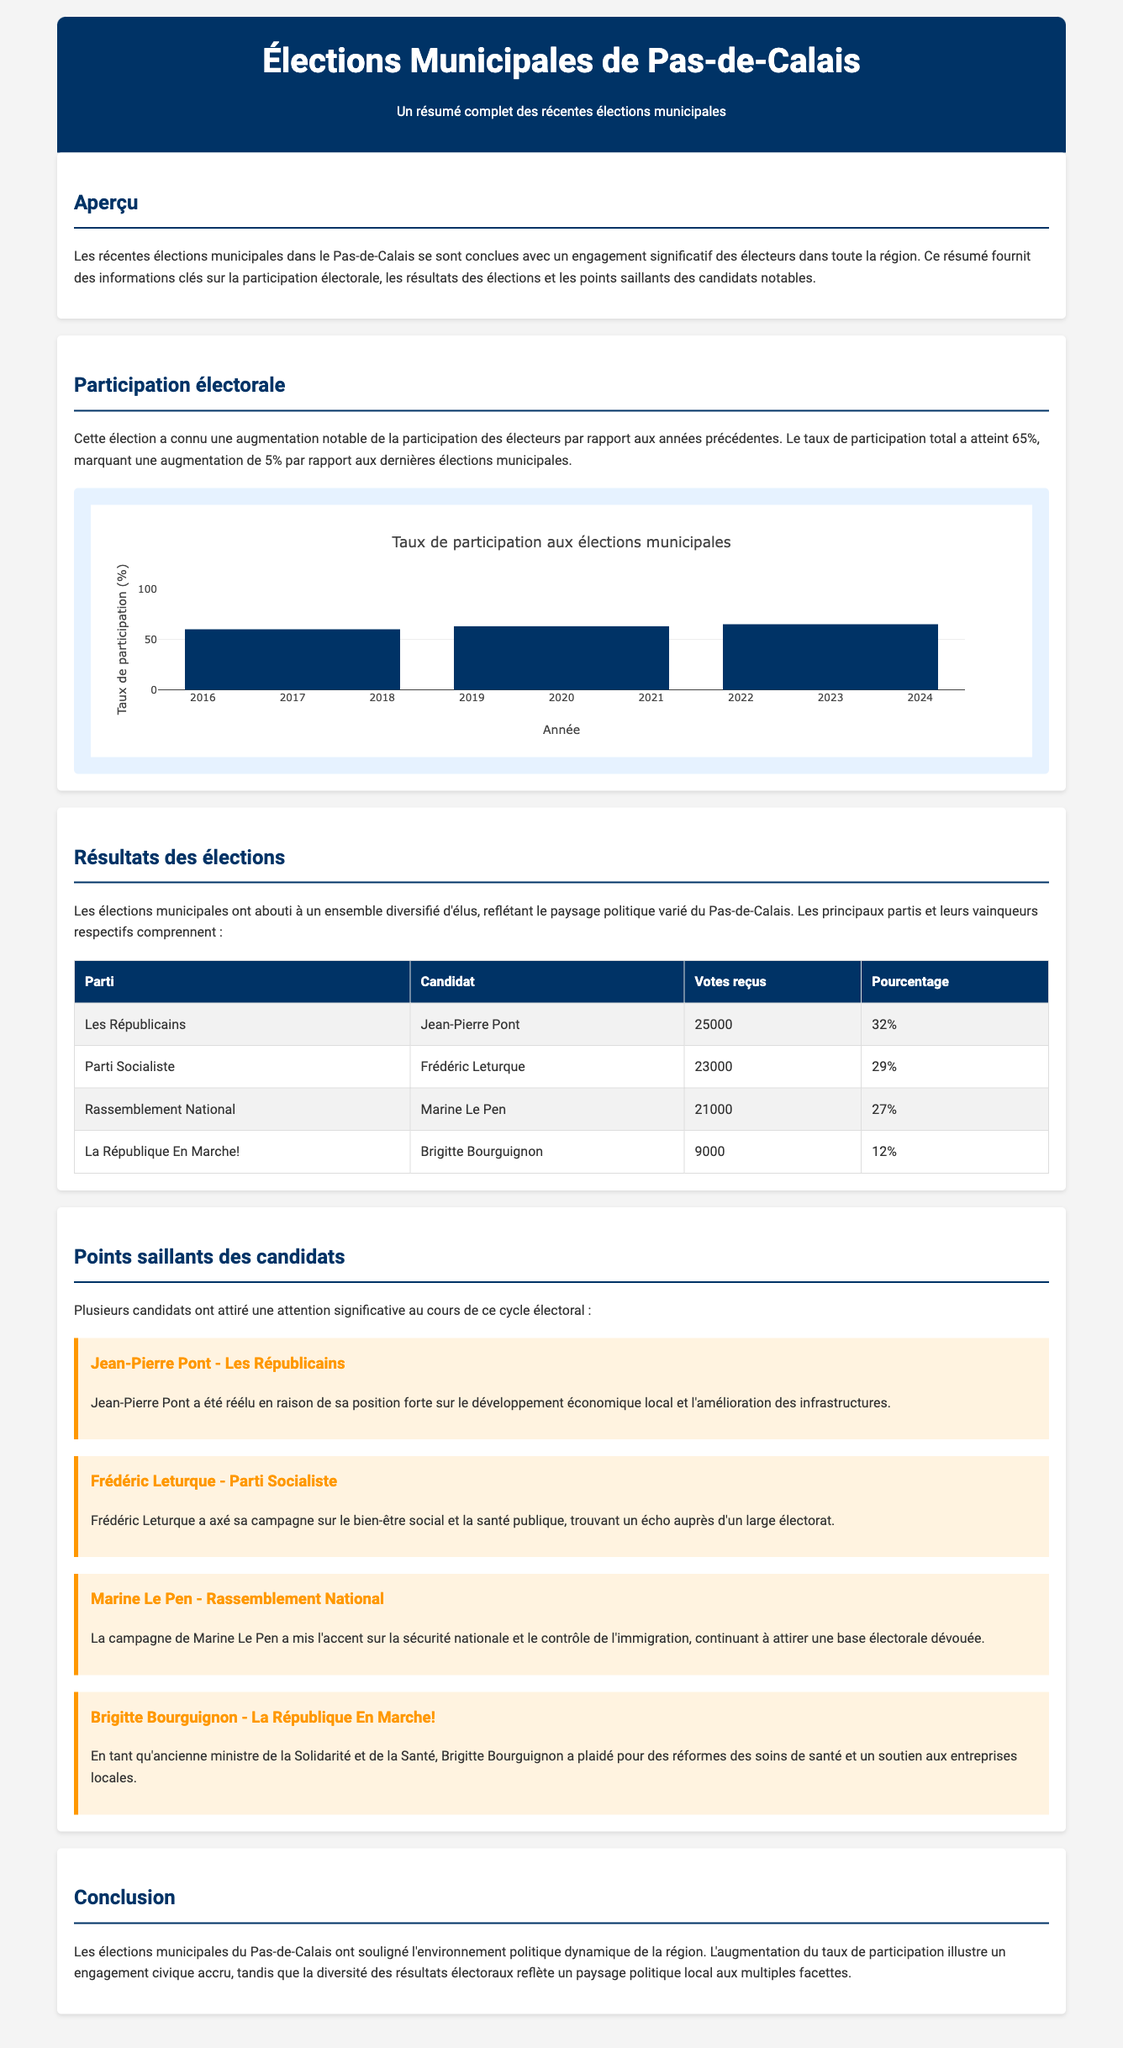What was the voter turnout rate? The voter turnout rate is mentioned in the section about electoral participation and is specified to be 65%.
Answer: 65% Who is the candidate for Les Républicains? The document lists Jean-Pierre Pont as the candidate for Les Républicains in the election results table.
Answer: Jean-Pierre Pont What percentage of votes did Marine Le Pen receive? The table in the election results section indicates that Marine Le Pen received 27% of the votes.
Answer: 27% Which candidate focused on social well-being and public health? Frédéric Leturque emphasized social well-being and health in his campaign, as noted in the candidate highlights.
Answer: Frédéric Leturque What is the title of the document? The title of the document is included in the header and describes the elections it covers.
Answer: Élections Municipales de Pas-de-Calais What was the increase in voter turnout from the last elections? The document compares the current turnout rate to the last election's and states it increased by 5%.
Answer: 5% Which party did Brigitte Bourguignon represent? The election results reference shows that Brigitte Bourguignon represented La République En Marche!.
Answer: La République En Marche! Which year had the highest voter turnout based on the infographic? The bar chart in the document shows that the year with the highest turnout is 2023.
Answer: 2023 